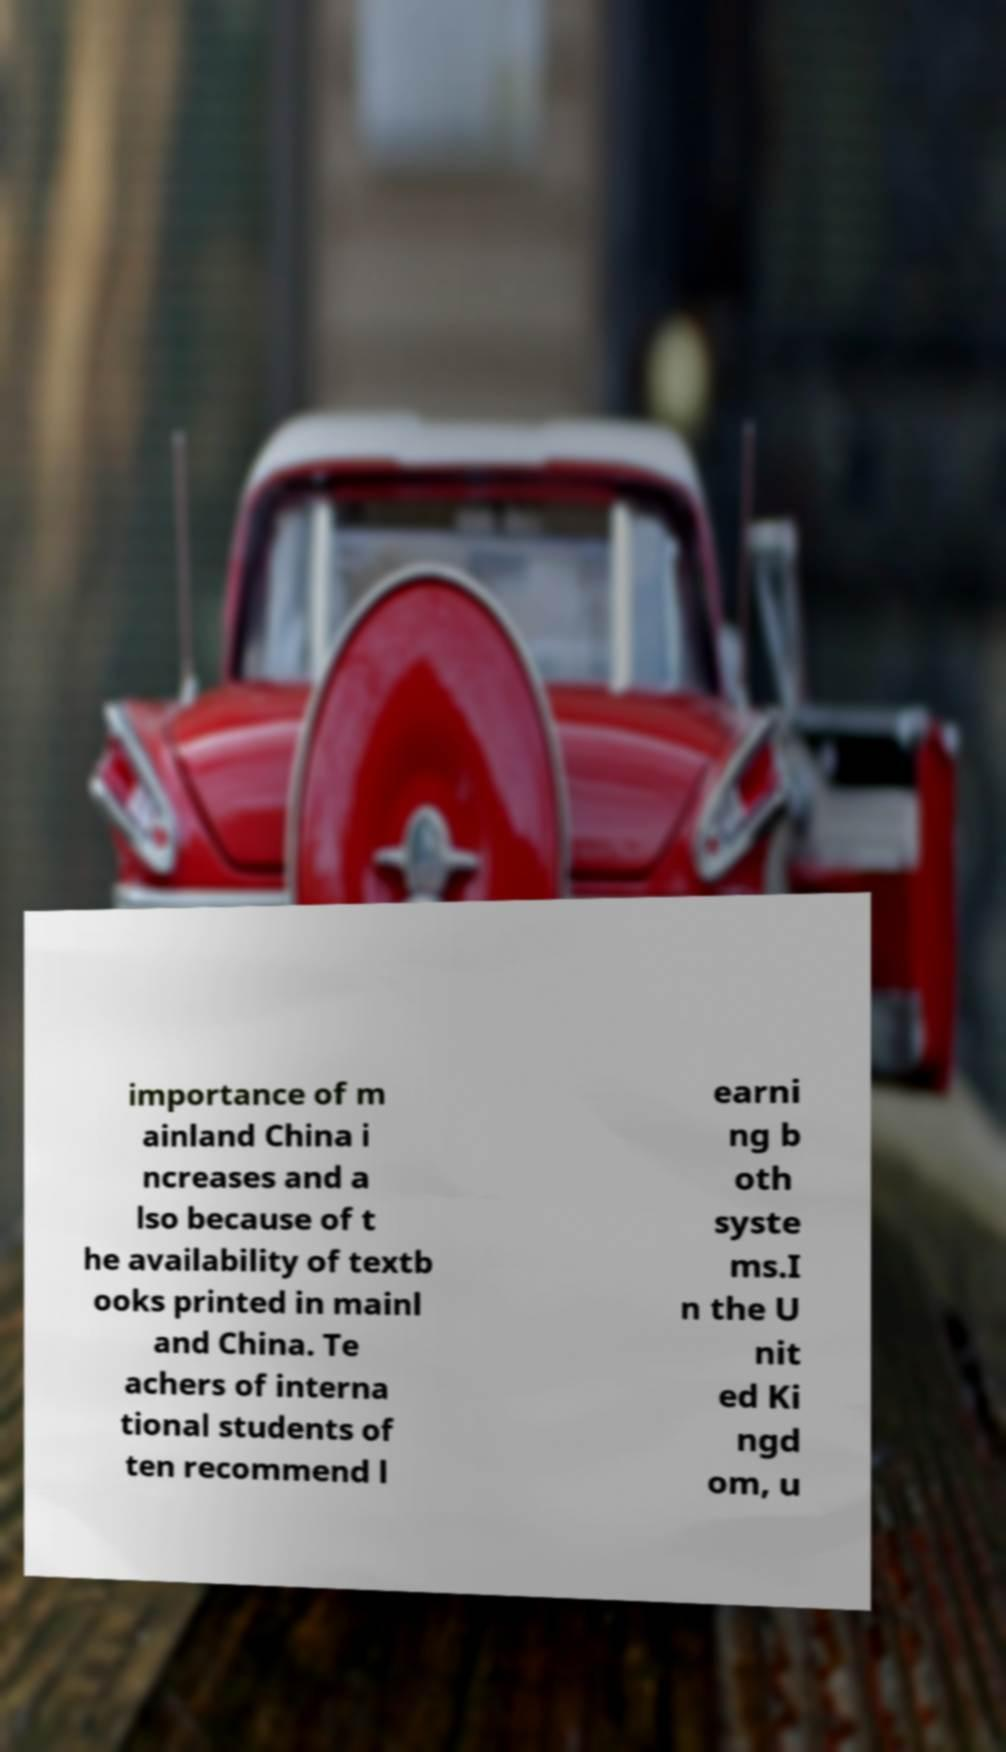Please read and relay the text visible in this image. What does it say? importance of m ainland China i ncreases and a lso because of t he availability of textb ooks printed in mainl and China. Te achers of interna tional students of ten recommend l earni ng b oth syste ms.I n the U nit ed Ki ngd om, u 